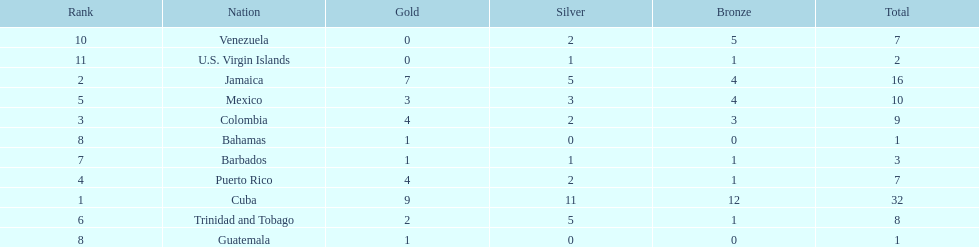Who had more silvers? colmbia or the bahamas Colombia. 